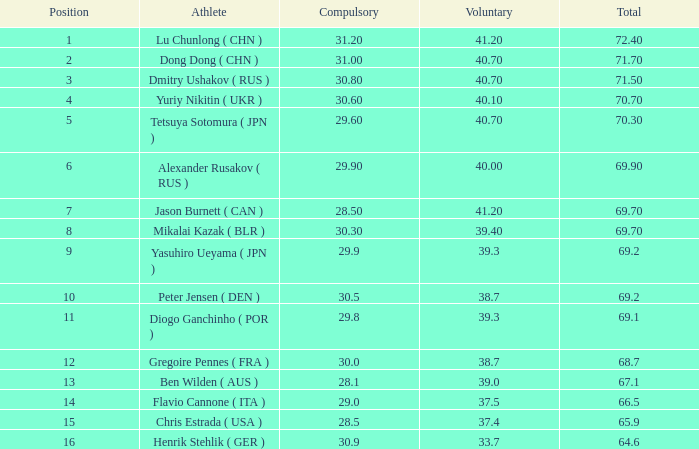What's the position that has a total less than 66.5m, a compulsory of 30.9 and voluntary less than 33.7? None. 